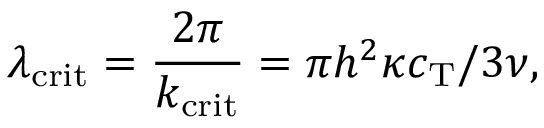<formula> <loc_0><loc_0><loc_500><loc_500>\lambda _ { c r i t } = \frac { 2 \pi } { k _ { c r i t } } = \pi h ^ { 2 } \kappa c _ { T } / 3 \nu ,</formula> 